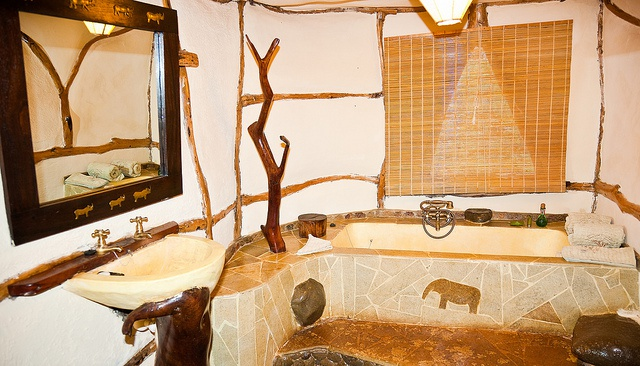Describe the objects in this image and their specific colors. I can see a sink in black, tan, and beige tones in this image. 